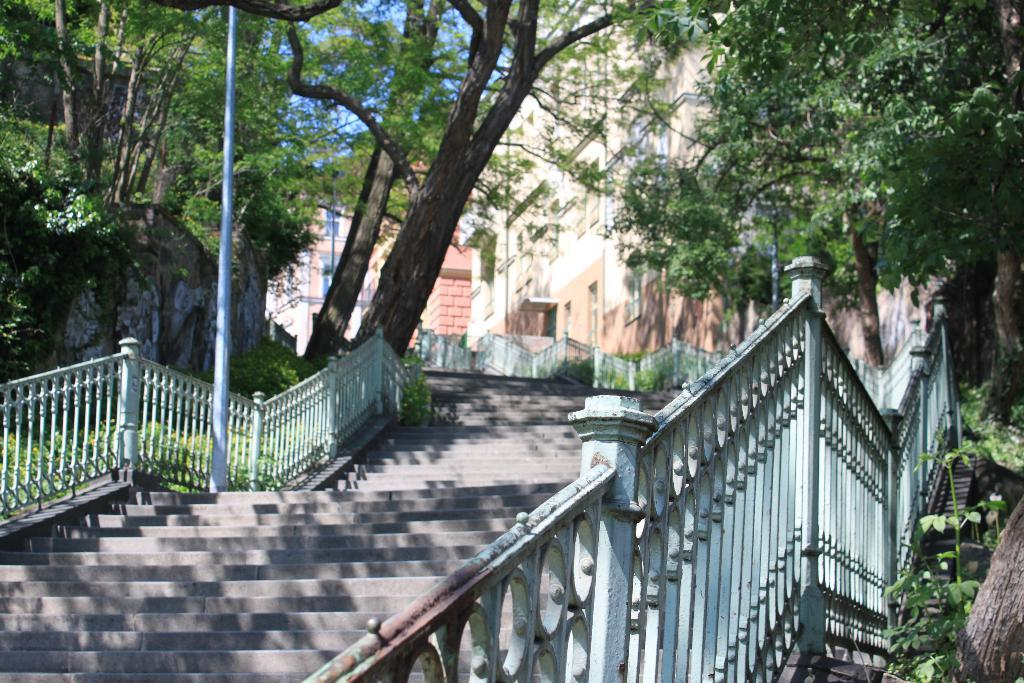What type of architectural feature is present in the image? There are staircases with fencing in the image. What can be seen in the background of the image? Trees and buildings are visible in the image. Where is the lunchroom located in the image? There is no lunchroom present in the image. What type of yoke can be seen attached to the trees in the image? There are no yokes present in the image, and the trees are not attached to any yokes. 